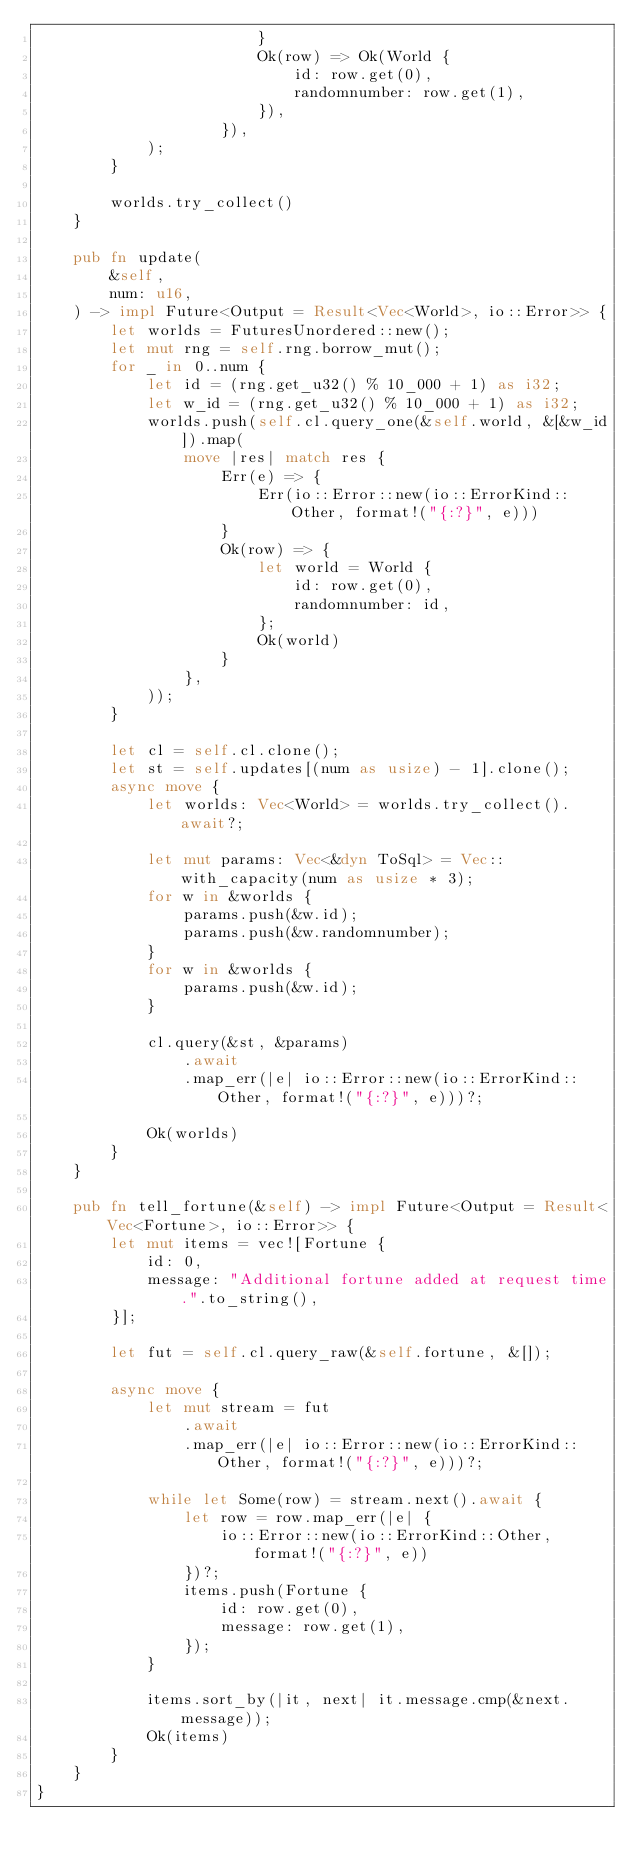<code> <loc_0><loc_0><loc_500><loc_500><_Rust_>                        }
                        Ok(row) => Ok(World {
                            id: row.get(0),
                            randomnumber: row.get(1),
                        }),
                    }),
            );
        }

        worlds.try_collect()
    }

    pub fn update(
        &self,
        num: u16,
    ) -> impl Future<Output = Result<Vec<World>, io::Error>> {
        let worlds = FuturesUnordered::new();
        let mut rng = self.rng.borrow_mut();
        for _ in 0..num {
            let id = (rng.get_u32() % 10_000 + 1) as i32;
            let w_id = (rng.get_u32() % 10_000 + 1) as i32;
            worlds.push(self.cl.query_one(&self.world, &[&w_id]).map(
                move |res| match res {
                    Err(e) => {
                        Err(io::Error::new(io::ErrorKind::Other, format!("{:?}", e)))
                    }
                    Ok(row) => {
                        let world = World {
                            id: row.get(0),
                            randomnumber: id,
                        };
                        Ok(world)
                    }
                },
            ));
        }

        let cl = self.cl.clone();
        let st = self.updates[(num as usize) - 1].clone();
        async move {
            let worlds: Vec<World> = worlds.try_collect().await?;

            let mut params: Vec<&dyn ToSql> = Vec::with_capacity(num as usize * 3);
            for w in &worlds {
                params.push(&w.id);
                params.push(&w.randomnumber);
            }
            for w in &worlds {
                params.push(&w.id);
            }

            cl.query(&st, &params)
                .await
                .map_err(|e| io::Error::new(io::ErrorKind::Other, format!("{:?}", e)))?;

            Ok(worlds)
        }
    }

    pub fn tell_fortune(&self) -> impl Future<Output = Result<Vec<Fortune>, io::Error>> {
        let mut items = vec![Fortune {
            id: 0,
            message: "Additional fortune added at request time.".to_string(),
        }];

        let fut = self.cl.query_raw(&self.fortune, &[]);

        async move {
            let mut stream = fut
                .await
                .map_err(|e| io::Error::new(io::ErrorKind::Other, format!("{:?}", e)))?;

            while let Some(row) = stream.next().await {
                let row = row.map_err(|e| {
                    io::Error::new(io::ErrorKind::Other, format!("{:?}", e))
                })?;
                items.push(Fortune {
                    id: row.get(0),
                    message: row.get(1),
                });
            }

            items.sort_by(|it, next| it.message.cmp(&next.message));
            Ok(items)
        }
    }
}
</code> 